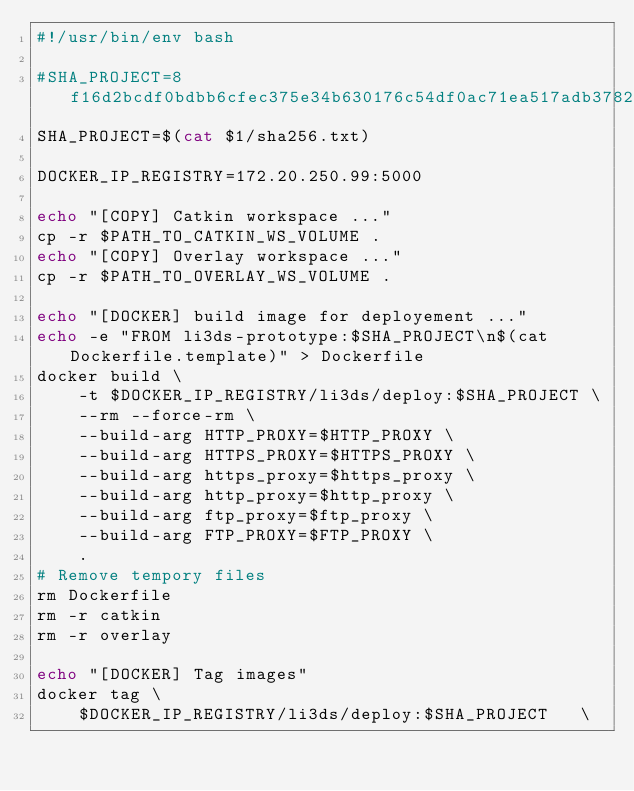<code> <loc_0><loc_0><loc_500><loc_500><_Bash_>#!/usr/bin/env bash

#SHA_PROJECT=8f16d2bcdf0bdbb6cfec375e34b630176c54df0ac71ea517adb3782be932727c
SHA_PROJECT=$(cat $1/sha256.txt)

DOCKER_IP_REGISTRY=172.20.250.99:5000

echo "[COPY] Catkin workspace ..."
cp -r $PATH_TO_CATKIN_WS_VOLUME .
echo "[COPY] Overlay workspace ..."
cp -r $PATH_TO_OVERLAY_WS_VOLUME .

echo "[DOCKER] build image for deployement ..."
echo -e "FROM li3ds-prototype:$SHA_PROJECT\n$(cat Dockerfile.template)" > Dockerfile
docker build \
    -t $DOCKER_IP_REGISTRY/li3ds/deploy:$SHA_PROJECT \
    --rm --force-rm \
    --build-arg HTTP_PROXY=$HTTP_PROXY \
    --build-arg HTTPS_PROXY=$HTTPS_PROXY \
    --build-arg https_proxy=$https_proxy \
    --build-arg http_proxy=$http_proxy \
    --build-arg ftp_proxy=$ftp_proxy \
    --build-arg FTP_PROXY=$FTP_PROXY \
    .
# Remove tempory files
rm Dockerfile
rm -r catkin
rm -r overlay

echo "[DOCKER] Tag images"
docker tag \
	$DOCKER_IP_REGISTRY/li3ds/deploy:$SHA_PROJECT	\</code> 